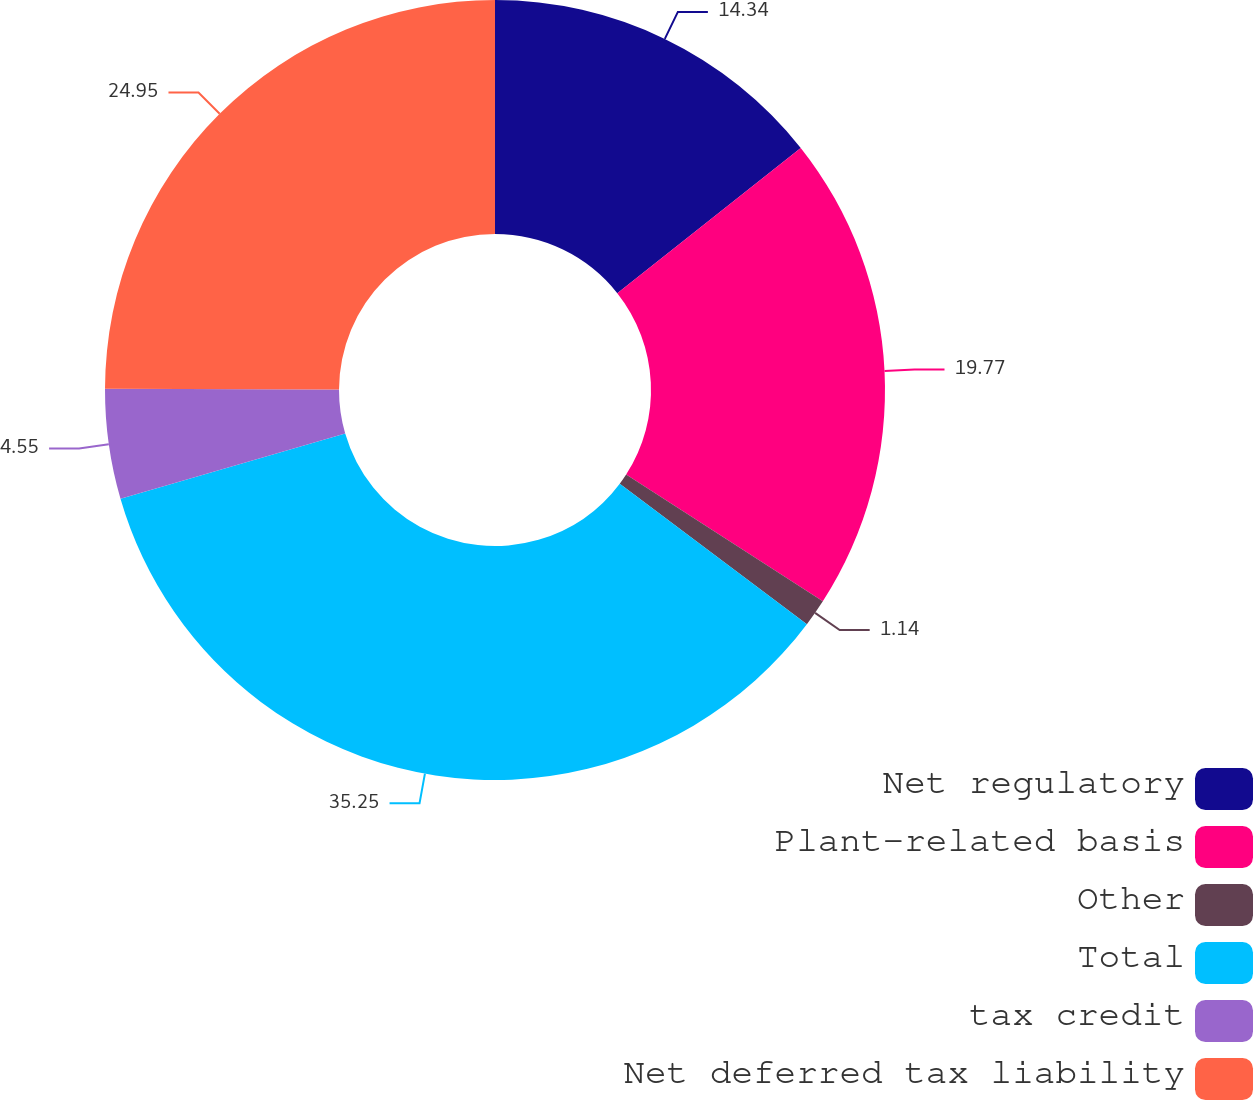<chart> <loc_0><loc_0><loc_500><loc_500><pie_chart><fcel>Net regulatory<fcel>Plant-related basis<fcel>Other<fcel>Total<fcel>tax credit<fcel>Net deferred tax liability<nl><fcel>14.34%<fcel>19.77%<fcel>1.14%<fcel>35.25%<fcel>4.55%<fcel>24.95%<nl></chart> 